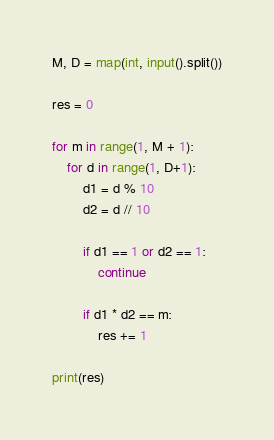Convert code to text. <code><loc_0><loc_0><loc_500><loc_500><_Python_>M, D = map(int, input().split())

res = 0

for m in range(1, M + 1):
    for d in range(1, D+1):
        d1 = d % 10
        d2 = d // 10

        if d1 == 1 or d2 == 1:
            continue

        if d1 * d2 == m:
            res += 1

print(res)
</code> 